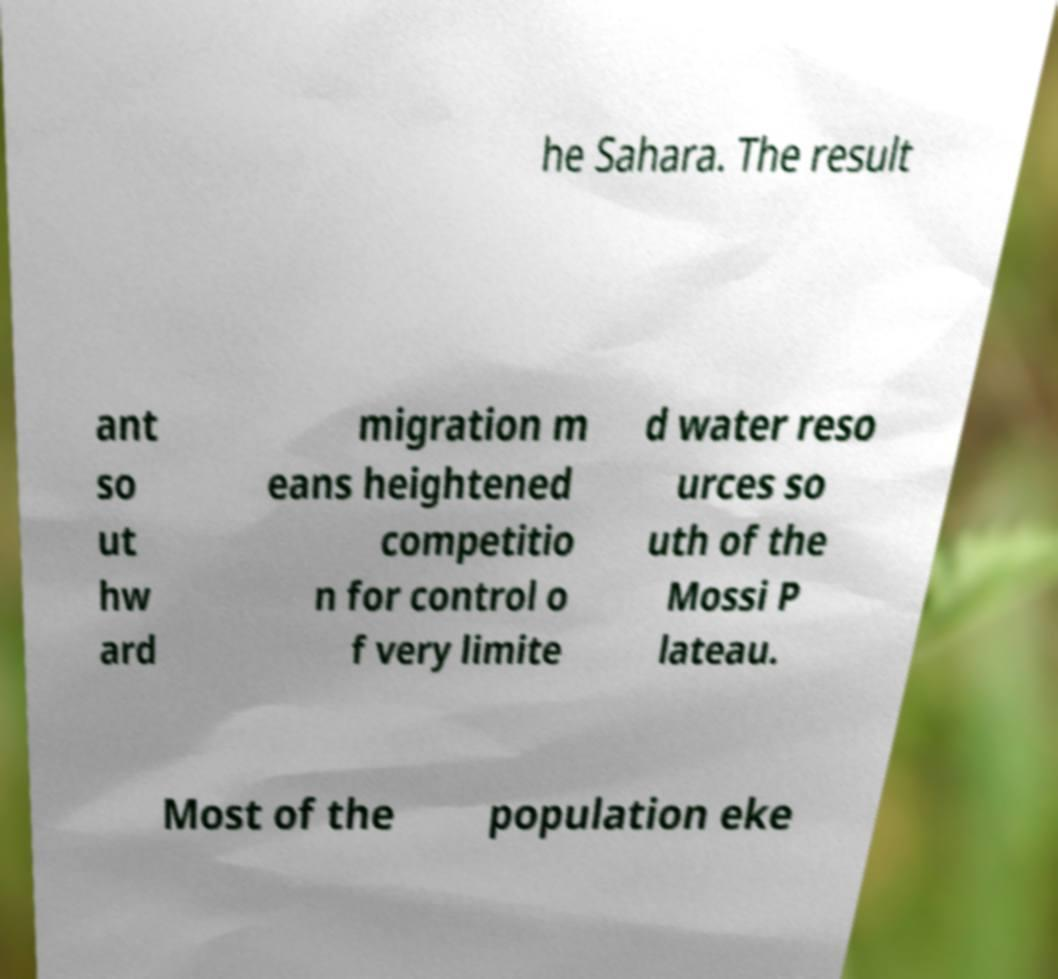There's text embedded in this image that I need extracted. Can you transcribe it verbatim? he Sahara. The result ant so ut hw ard migration m eans heightened competitio n for control o f very limite d water reso urces so uth of the Mossi P lateau. Most of the population eke 